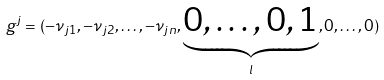<formula> <loc_0><loc_0><loc_500><loc_500>g ^ { j } = ( - \nu _ { j 1 } , - \nu _ { j 2 } , \dots , - \nu _ { j n } , \underbrace { 0 , \dots , 0 , 1 } _ { l } , 0 , \dots , 0 )</formula> 